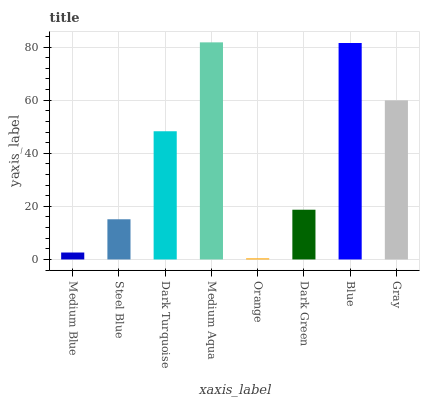Is Orange the minimum?
Answer yes or no. Yes. Is Medium Aqua the maximum?
Answer yes or no. Yes. Is Steel Blue the minimum?
Answer yes or no. No. Is Steel Blue the maximum?
Answer yes or no. No. Is Steel Blue greater than Medium Blue?
Answer yes or no. Yes. Is Medium Blue less than Steel Blue?
Answer yes or no. Yes. Is Medium Blue greater than Steel Blue?
Answer yes or no. No. Is Steel Blue less than Medium Blue?
Answer yes or no. No. Is Dark Turquoise the high median?
Answer yes or no. Yes. Is Dark Green the low median?
Answer yes or no. Yes. Is Medium Blue the high median?
Answer yes or no. No. Is Steel Blue the low median?
Answer yes or no. No. 